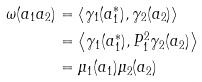Convert formula to latex. <formula><loc_0><loc_0><loc_500><loc_500>\omega ( a _ { 1 } a _ { 2 } ) & = \left \langle \gamma _ { 1 } ( a _ { 1 } ^ { \ast } ) , \gamma _ { 2 } ( a _ { 2 } ) \right \rangle \\ & = \left \langle \gamma _ { 1 } ( a _ { 1 } ^ { \ast } ) , P _ { 1 } ^ { 2 } \gamma _ { 2 } ( a _ { 2 } ) \right \rangle \\ & = \mu _ { 1 } ( a _ { 1 } ) \mu _ { 2 } ( a _ { 2 } )</formula> 